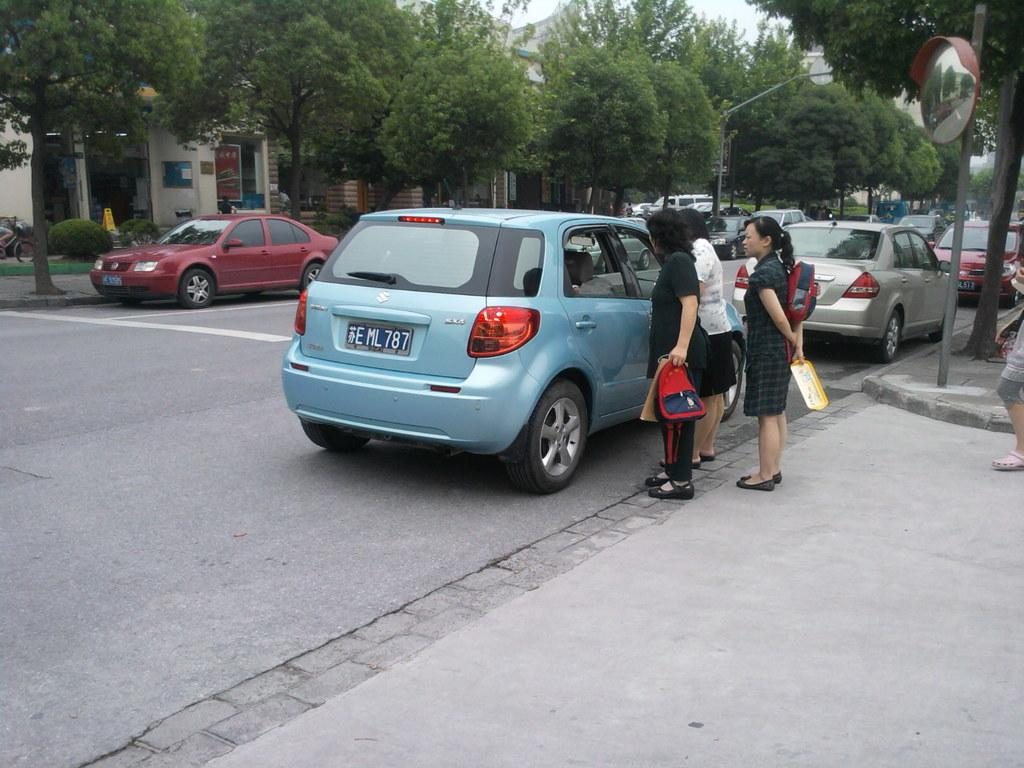What can be seen on the road in the image? There are cars parked on the road in the image. Can you describe the color of one of the cars? There is a blue car among the parked cars. What is happening near the blue car? Three women are standing beside the blue car. What is visible in the background of the image? There are buildings and trees in the background of the image. What verse is being recited by the clock in the image? There is no clock present in the image, and therefore no verse can be recited. 